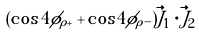Convert formula to latex. <formula><loc_0><loc_0><loc_500><loc_500>( \cos 4 \phi _ { \rho + } + \cos 4 \phi _ { \rho - } ) \vec { J } _ { 1 } \cdot \vec { J } _ { 2 }</formula> 